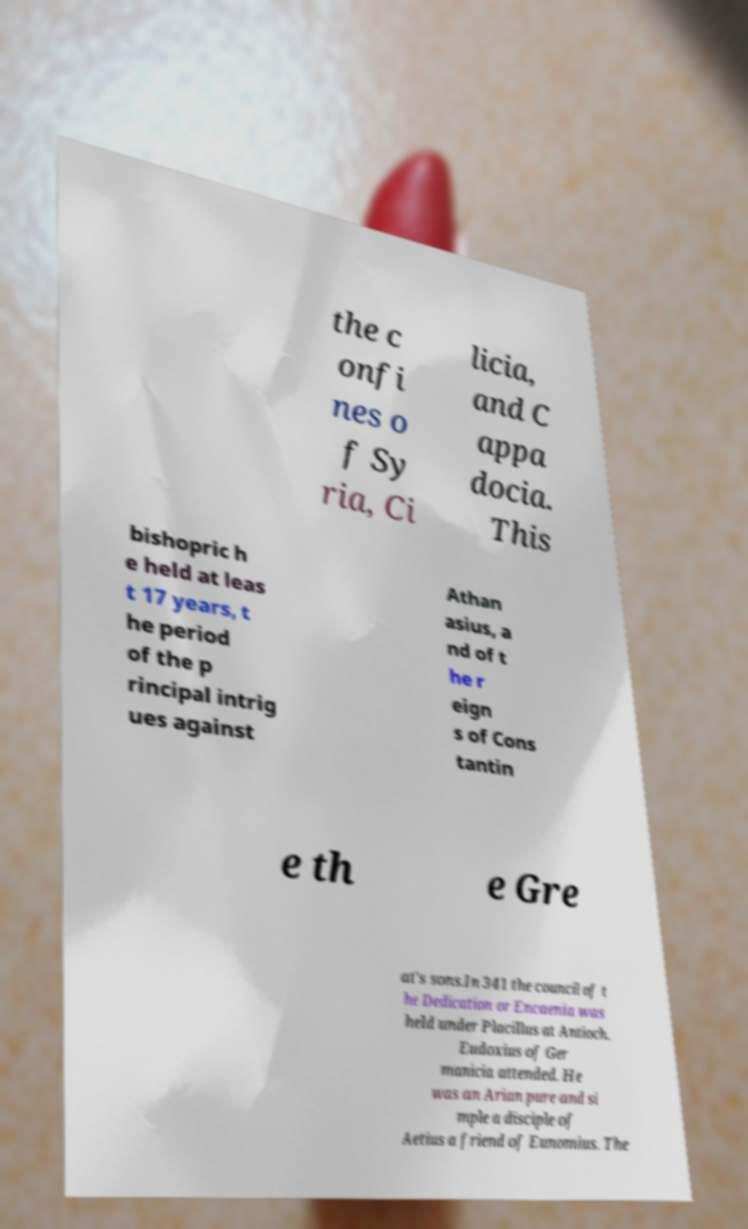There's text embedded in this image that I need extracted. Can you transcribe it verbatim? the c onfi nes o f Sy ria, Ci licia, and C appa docia. This bishopric h e held at leas t 17 years, t he period of the p rincipal intrig ues against Athan asius, a nd of t he r eign s of Cons tantin e th e Gre at's sons.In 341 the council of t he Dedication or Encaenia was held under Placillus at Antioch. Eudoxius of Ger manicia attended. He was an Arian pure and si mple a disciple of Aetius a friend of Eunomius. The 